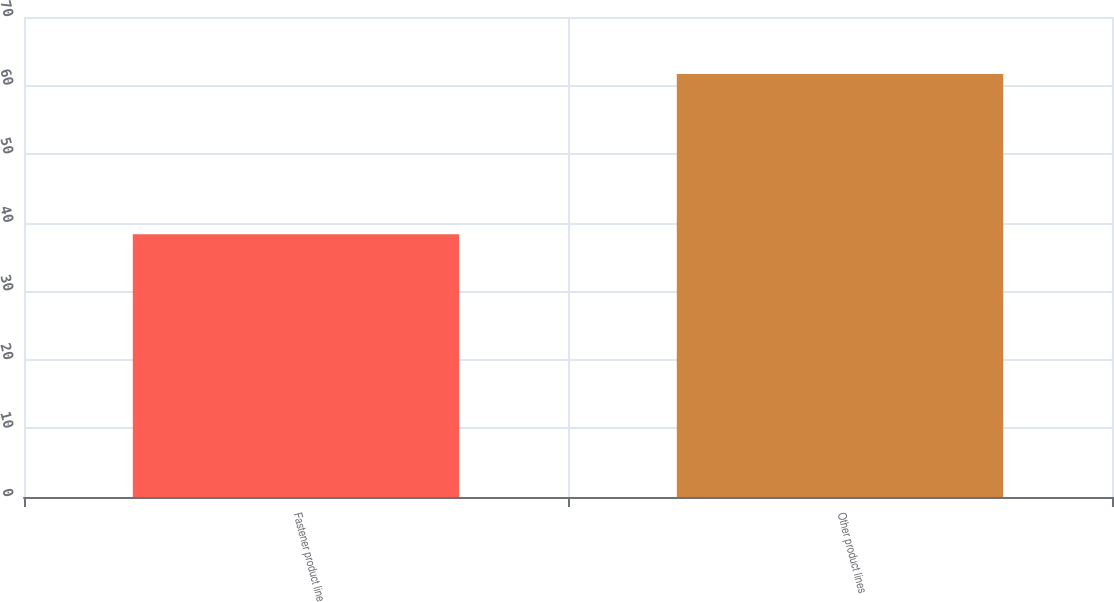<chart> <loc_0><loc_0><loc_500><loc_500><bar_chart><fcel>Fastener product line<fcel>Other product lines<nl><fcel>38.3<fcel>61.7<nl></chart> 